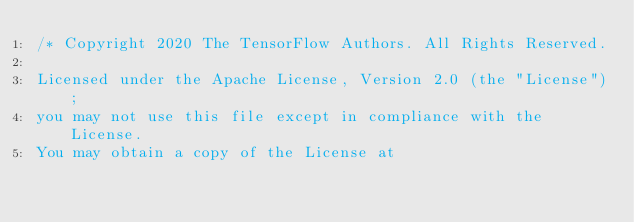Convert code to text. <code><loc_0><loc_0><loc_500><loc_500><_C++_>/* Copyright 2020 The TensorFlow Authors. All Rights Reserved.

Licensed under the Apache License, Version 2.0 (the "License");
you may not use this file except in compliance with the License.
You may obtain a copy of the License at
</code> 